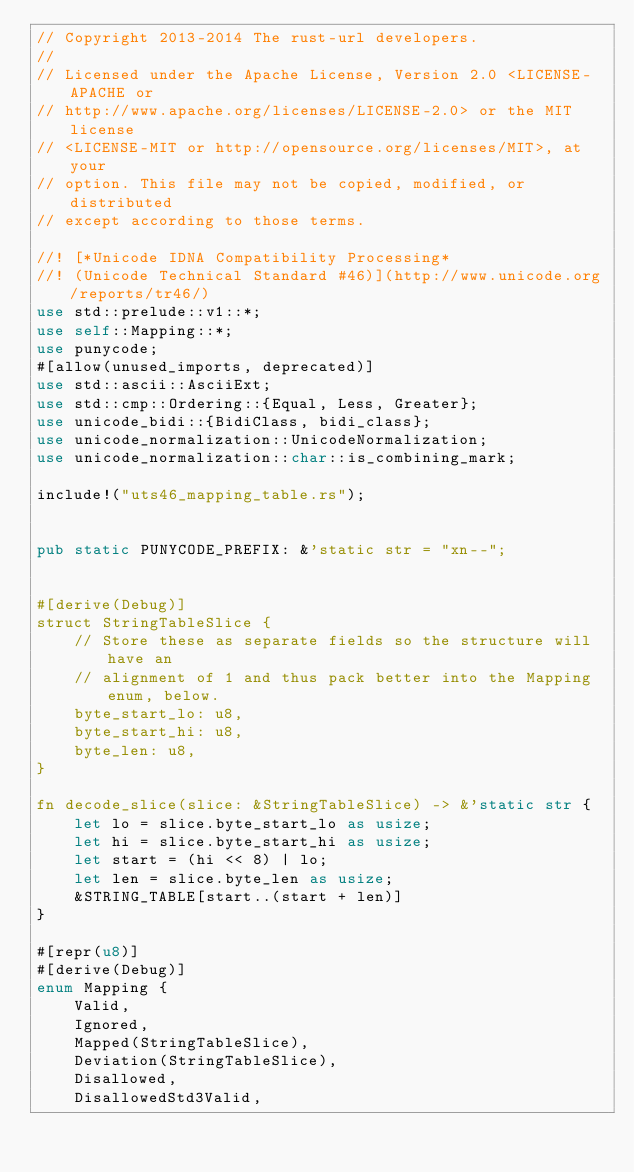<code> <loc_0><loc_0><loc_500><loc_500><_Rust_>// Copyright 2013-2014 The rust-url developers.
//
// Licensed under the Apache License, Version 2.0 <LICENSE-APACHE or
// http://www.apache.org/licenses/LICENSE-2.0> or the MIT license
// <LICENSE-MIT or http://opensource.org/licenses/MIT>, at your
// option. This file may not be copied, modified, or distributed
// except according to those terms.

//! [*Unicode IDNA Compatibility Processing*
//! (Unicode Technical Standard #46)](http://www.unicode.org/reports/tr46/)
use std::prelude::v1::*;
use self::Mapping::*;
use punycode;
#[allow(unused_imports, deprecated)]
use std::ascii::AsciiExt;
use std::cmp::Ordering::{Equal, Less, Greater};
use unicode_bidi::{BidiClass, bidi_class};
use unicode_normalization::UnicodeNormalization;
use unicode_normalization::char::is_combining_mark;

include!("uts46_mapping_table.rs");


pub static PUNYCODE_PREFIX: &'static str = "xn--";


#[derive(Debug)]
struct StringTableSlice {
    // Store these as separate fields so the structure will have an
    // alignment of 1 and thus pack better into the Mapping enum, below.
    byte_start_lo: u8,
    byte_start_hi: u8,
    byte_len: u8,
}

fn decode_slice(slice: &StringTableSlice) -> &'static str {
    let lo = slice.byte_start_lo as usize;
    let hi = slice.byte_start_hi as usize;
    let start = (hi << 8) | lo;
    let len = slice.byte_len as usize;
    &STRING_TABLE[start..(start + len)]
}

#[repr(u8)]
#[derive(Debug)]
enum Mapping {
    Valid,
    Ignored,
    Mapped(StringTableSlice),
    Deviation(StringTableSlice),
    Disallowed,
    DisallowedStd3Valid,</code> 